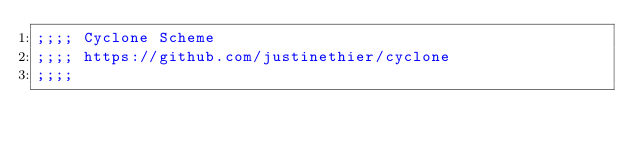Convert code to text. <code><loc_0><loc_0><loc_500><loc_500><_Scheme_>;;;; Cyclone Scheme
;;;; https://github.com/justinethier/cyclone
;;;;</code> 